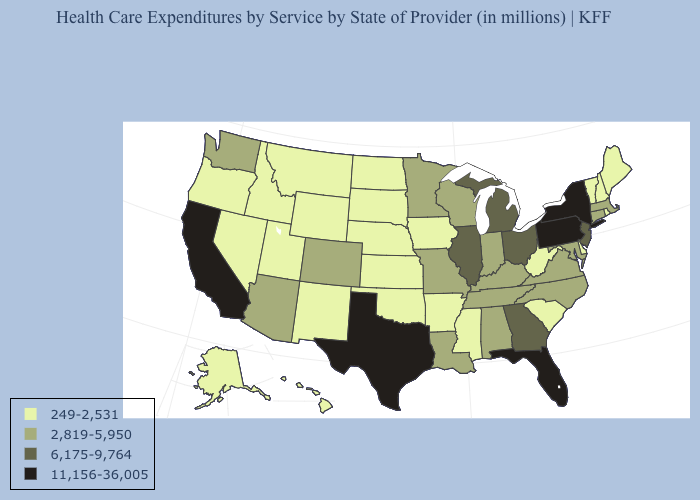Does Texas have the highest value in the USA?
Concise answer only. Yes. Among the states that border South Dakota , which have the highest value?
Quick response, please. Minnesota. Name the states that have a value in the range 249-2,531?
Quick response, please. Alaska, Arkansas, Delaware, Hawaii, Idaho, Iowa, Kansas, Maine, Mississippi, Montana, Nebraska, Nevada, New Hampshire, New Mexico, North Dakota, Oklahoma, Oregon, Rhode Island, South Carolina, South Dakota, Utah, Vermont, West Virginia, Wyoming. Name the states that have a value in the range 11,156-36,005?
Write a very short answer. California, Florida, New York, Pennsylvania, Texas. Is the legend a continuous bar?
Keep it brief. No. Name the states that have a value in the range 6,175-9,764?
Give a very brief answer. Georgia, Illinois, Michigan, New Jersey, Ohio. Does the first symbol in the legend represent the smallest category?
Answer briefly. Yes. What is the value of California?
Quick response, please. 11,156-36,005. Name the states that have a value in the range 6,175-9,764?
Quick response, please. Georgia, Illinois, Michigan, New Jersey, Ohio. Name the states that have a value in the range 6,175-9,764?
Concise answer only. Georgia, Illinois, Michigan, New Jersey, Ohio. Does the map have missing data?
Be succinct. No. Which states have the highest value in the USA?
Quick response, please. California, Florida, New York, Pennsylvania, Texas. Which states hav the highest value in the South?
Answer briefly. Florida, Texas. Which states have the highest value in the USA?
Quick response, please. California, Florida, New York, Pennsylvania, Texas. Among the states that border North Dakota , does Minnesota have the lowest value?
Be succinct. No. 